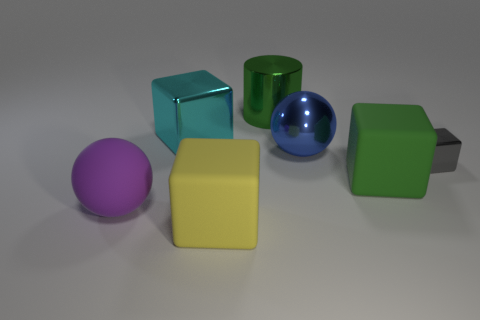What number of metallic objects are big blue balls or blocks?
Ensure brevity in your answer.  3. Are there any matte balls that are on the right side of the big object on the left side of the block behind the small gray metal block?
Your response must be concise. No. There is a yellow rubber cube; what number of shiny objects are to the right of it?
Offer a very short reply. 3. There is a large object that is the same color as the cylinder; what is it made of?
Your answer should be compact. Rubber. How many large objects are metallic cylinders or blue metallic things?
Ensure brevity in your answer.  2. There is a green thing that is behind the small metal block; what shape is it?
Your response must be concise. Cylinder. Are there any objects that have the same color as the large shiny sphere?
Give a very brief answer. No. Does the cube to the left of the yellow thing have the same size as the gray thing that is in front of the blue sphere?
Make the answer very short. No. Are there more big yellow blocks to the left of the big cyan object than metallic things that are behind the blue metal ball?
Make the answer very short. No. Are there any big green blocks made of the same material as the big cylinder?
Keep it short and to the point. No. 